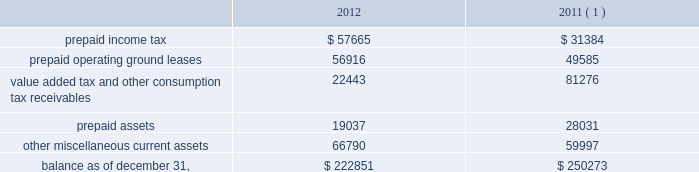American tower corporation and subsidiaries notes to consolidated financial statements loss on retirement of long-term obligations 2014loss on retirement of long-term obligations primarily includes cash paid to retire debt in excess of its carrying value , cash paid to holders of convertible notes in connection with note conversions and non-cash charges related to the write-off of deferred financing fees .
Loss on retirement of long-term obligations also includes gains from repurchasing or refinancing certain of the company 2019s debt obligations .
Earnings per common share 2014basic and diluted 2014basic income from continuing operations per common share for the years ended december 31 , 2012 , 2011 and 2010 represents income from continuing operations attributable to american tower corporation divided by the weighted average number of common shares outstanding during the period .
Diluted income from continuing operations per common share for the years ended december 31 , 2012 , 2011 and 2010 represents income from continuing operations attributable to american tower corporation divided by the weighted average number of common shares outstanding during the period and any dilutive common share equivalents , including unvested restricted stock , shares issuable upon exercise of stock options and warrants as determined under the treasury stock method and upon conversion of the company 2019s convertible notes , as determined under the if-converted method .
Retirement plan 2014the company has a 401 ( k ) plan covering substantially all employees who meet certain age and employment requirements .
The company 2019s matching contribution for the years ended december 31 , 2012 , 2011 and 2010 is 50% ( 50 % ) up to a maximum 6% ( 6 % ) of a participant 2019s contributions .
For the years ended december 31 , 2012 , 2011 and 2010 , the company contributed approximately $ 4.4 million , $ 2.9 million and $ 1.9 million to the plan , respectively .
Prepaid and other current assets prepaid and other current assets consist of the following as of december 31 , ( in thousands ) : .
( 1 ) december 31 , 2011 balances have been revised to reflect purchase accounting measurement period adjustments. .
What was the average company contribution to the retirement plan from 2010 to 2012? 
Computations: ((1.9 + (4.4 / 2.9)) / 3)
Answer: 1.13908. 